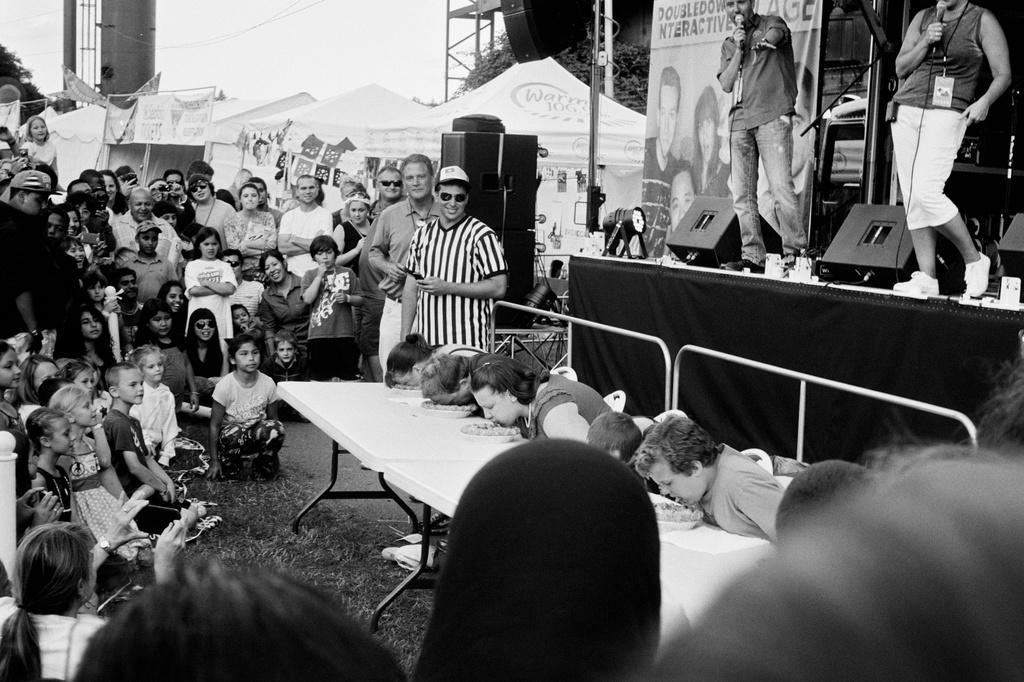Describe this image in one or two sentences. In the middle of the image there is a table on the table there are some plates and there are few women sitting on chairs. Top right side of the image two persons are standing and holding microphones. Behind them there is a banner. Top left side of the image few people are standing. Bottom left side of the image few people are sitting and watching. Top of the image there is a sky and there are some trees. 